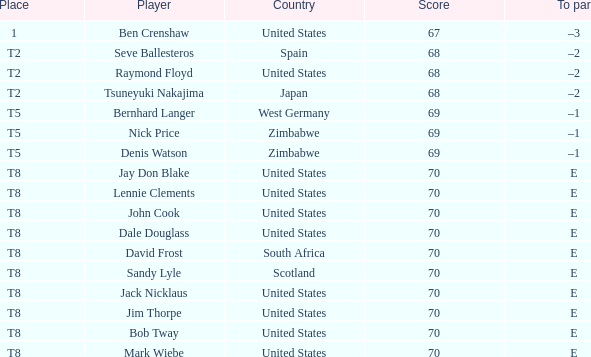What competitor has e as the best par, and the united states as their homeland? Jay Don Blake, Lennie Clements, John Cook, Dale Douglass, Jack Nicklaus, Jim Thorpe, Bob Tway, Mark Wiebe. 